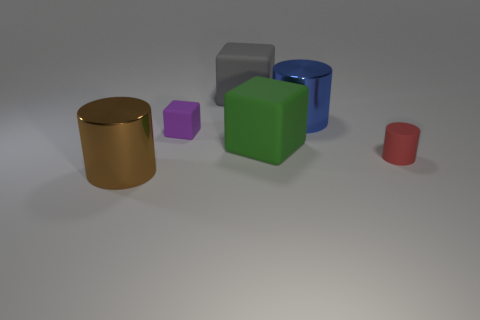Subtract all blue metal cylinders. How many cylinders are left? 2 Subtract 1 blocks. How many blocks are left? 2 Add 2 purple objects. How many objects exist? 8 Add 4 large gray rubber cubes. How many large gray rubber cubes are left? 5 Add 2 big gray rubber blocks. How many big gray rubber blocks exist? 3 Subtract 1 brown cylinders. How many objects are left? 5 Subtract all large blue shiny things. Subtract all gray cubes. How many objects are left? 4 